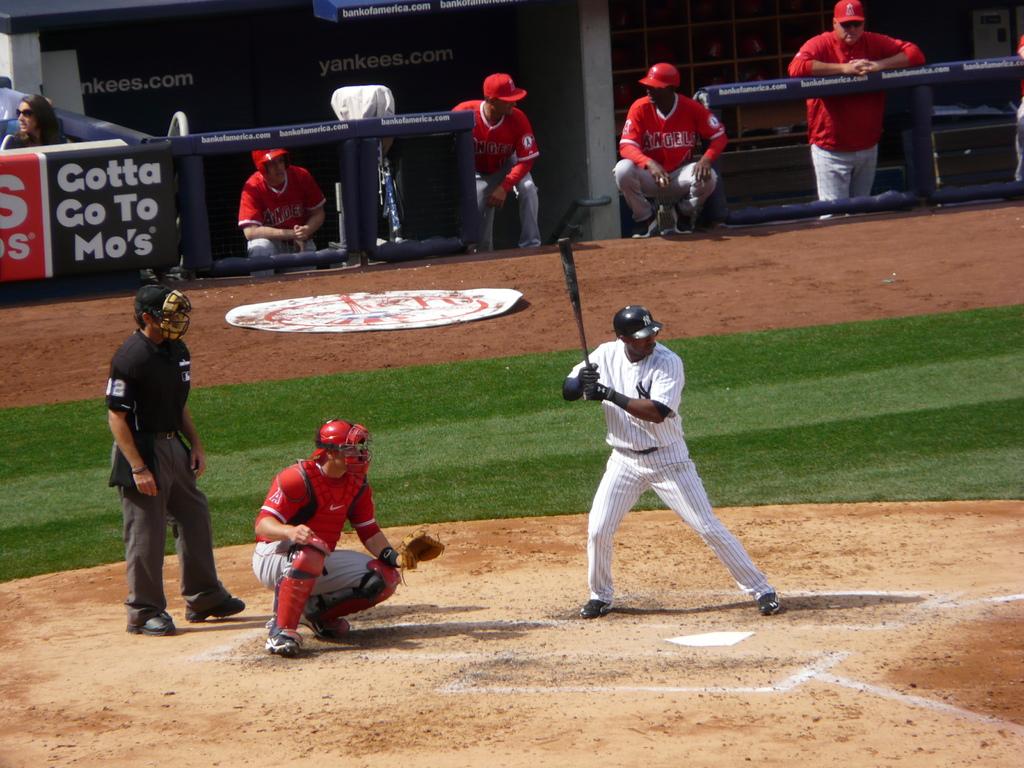What does the advertisement say you have to go to?
Ensure brevity in your answer.  Mo's. 